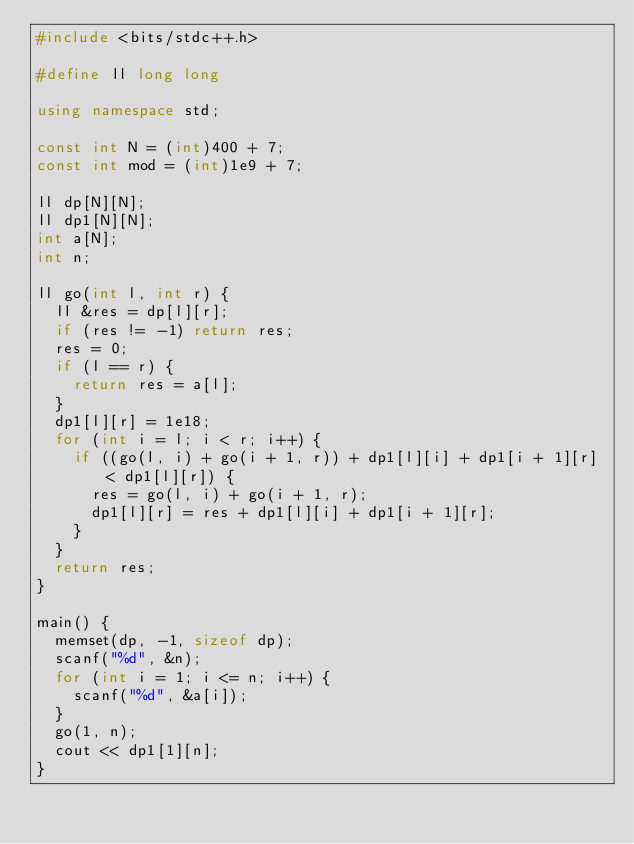<code> <loc_0><loc_0><loc_500><loc_500><_C++_>#include <bits/stdc++.h>

#define ll long long

using namespace std;

const int N = (int)400 + 7;
const int mod = (int)1e9 + 7;

ll dp[N][N];
ll dp1[N][N];
int a[N];
int n;

ll go(int l, int r) {
	ll &res = dp[l][r];
	if (res != -1) return res;
	res = 0;
	if (l == r) {
		return res = a[l];
	}
	dp1[l][r] = 1e18;
	for (int i = l; i < r; i++) {
		if ((go(l, i) + go(i + 1, r)) + dp1[l][i] + dp1[i + 1][r] < dp1[l][r]) {
			res = go(l, i) + go(i + 1, r);
			dp1[l][r] = res + dp1[l][i] + dp1[i + 1][r];
		}
	}
	return res;
}

main() {
	memset(dp, -1, sizeof dp);
	scanf("%d", &n);
	for (int i = 1; i <= n; i++) {
		scanf("%d", &a[i]);
	}
	go(1, n);
	cout << dp1[1][n];
}
</code> 